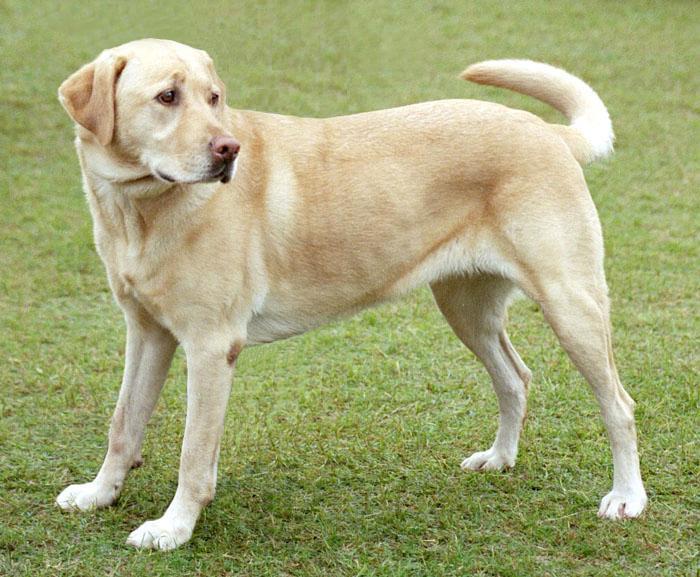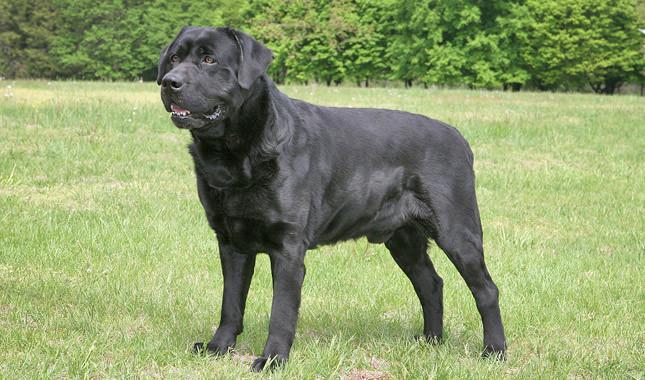The first image is the image on the left, the second image is the image on the right. Examine the images to the left and right. Is the description "The right image shows exactly two puppies side by side." accurate? Answer yes or no. No. The first image is the image on the left, the second image is the image on the right. Analyze the images presented: Is the assertion "There is one black dog" valid? Answer yes or no. Yes. 